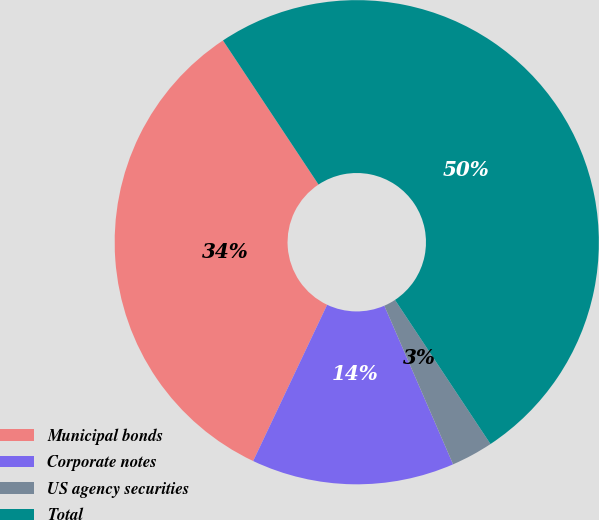Convert chart. <chart><loc_0><loc_0><loc_500><loc_500><pie_chart><fcel>Municipal bonds<fcel>Corporate notes<fcel>US agency securities<fcel>Total<nl><fcel>33.64%<fcel>13.55%<fcel>2.8%<fcel>50.0%<nl></chart> 